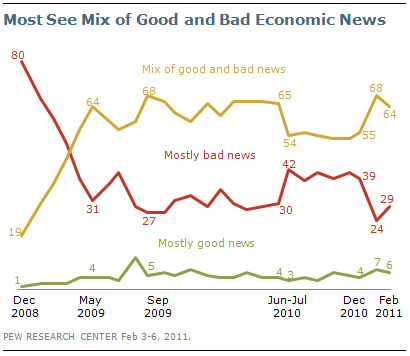Outline some significant characteristics in this image. The combined value of the highest green line and the highest orange line is 75. The lowest value of the green line is 1. 